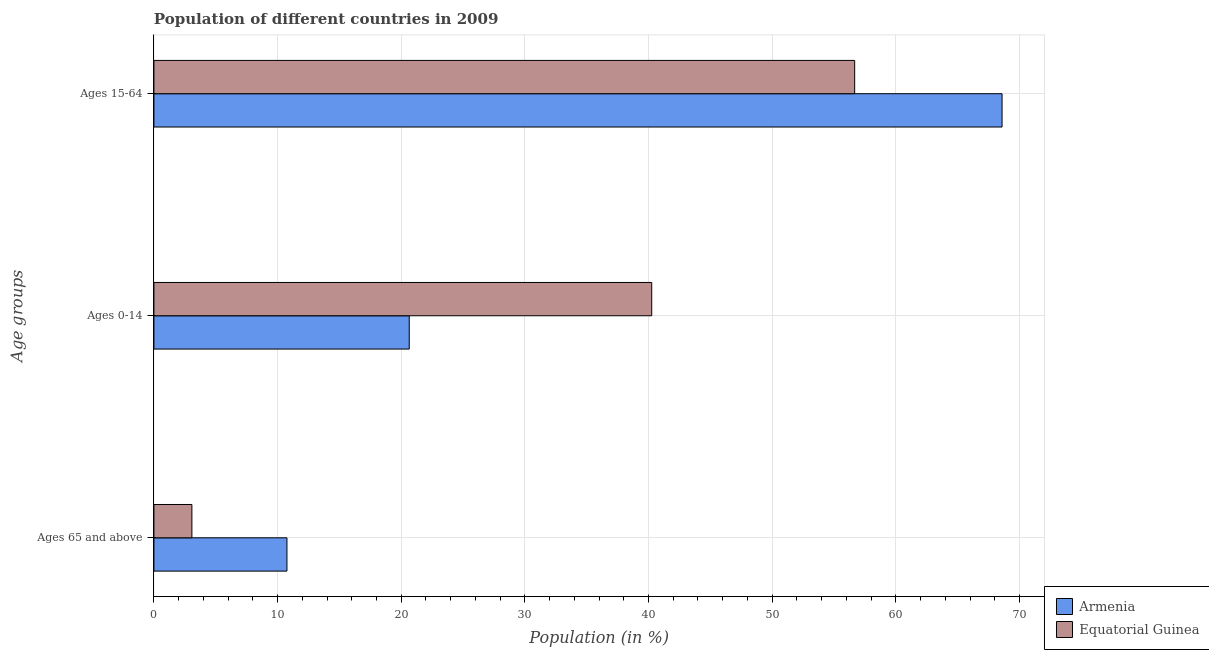How many groups of bars are there?
Offer a very short reply. 3. Are the number of bars on each tick of the Y-axis equal?
Give a very brief answer. Yes. How many bars are there on the 2nd tick from the bottom?
Your answer should be very brief. 2. What is the label of the 3rd group of bars from the top?
Keep it short and to the point. Ages 65 and above. What is the percentage of population within the age-group 0-14 in Armenia?
Keep it short and to the point. 20.65. Across all countries, what is the maximum percentage of population within the age-group of 65 and above?
Ensure brevity in your answer.  10.76. Across all countries, what is the minimum percentage of population within the age-group of 65 and above?
Offer a very short reply. 3.07. In which country was the percentage of population within the age-group of 65 and above maximum?
Your response must be concise. Armenia. In which country was the percentage of population within the age-group 0-14 minimum?
Provide a succinct answer. Armenia. What is the total percentage of population within the age-group 0-14 in the graph?
Your response must be concise. 60.91. What is the difference between the percentage of population within the age-group 0-14 in Armenia and that in Equatorial Guinea?
Offer a very short reply. -19.61. What is the difference between the percentage of population within the age-group 15-64 in Armenia and the percentage of population within the age-group 0-14 in Equatorial Guinea?
Your answer should be compact. 28.33. What is the average percentage of population within the age-group 15-64 per country?
Make the answer very short. 62.63. What is the difference between the percentage of population within the age-group 15-64 and percentage of population within the age-group 0-14 in Equatorial Guinea?
Your answer should be compact. 16.41. In how many countries, is the percentage of population within the age-group 15-64 greater than 6 %?
Provide a succinct answer. 2. What is the ratio of the percentage of population within the age-group 0-14 in Equatorial Guinea to that in Armenia?
Make the answer very short. 1.95. Is the difference between the percentage of population within the age-group of 65 and above in Equatorial Guinea and Armenia greater than the difference between the percentage of population within the age-group 15-64 in Equatorial Guinea and Armenia?
Keep it short and to the point. Yes. What is the difference between the highest and the second highest percentage of population within the age-group 0-14?
Make the answer very short. 19.61. What is the difference between the highest and the lowest percentage of population within the age-group 15-64?
Keep it short and to the point. 11.92. What does the 2nd bar from the top in Ages 15-64 represents?
Offer a very short reply. Armenia. What does the 1st bar from the bottom in Ages 65 and above represents?
Provide a succinct answer. Armenia. Is it the case that in every country, the sum of the percentage of population within the age-group of 65 and above and percentage of population within the age-group 0-14 is greater than the percentage of population within the age-group 15-64?
Make the answer very short. No. How many bars are there?
Ensure brevity in your answer.  6. Are all the bars in the graph horizontal?
Your answer should be compact. Yes. Are the values on the major ticks of X-axis written in scientific E-notation?
Offer a very short reply. No. Does the graph contain any zero values?
Make the answer very short. No. Does the graph contain grids?
Give a very brief answer. Yes. How are the legend labels stacked?
Provide a short and direct response. Vertical. What is the title of the graph?
Make the answer very short. Population of different countries in 2009. Does "Barbados" appear as one of the legend labels in the graph?
Keep it short and to the point. No. What is the label or title of the X-axis?
Your response must be concise. Population (in %). What is the label or title of the Y-axis?
Offer a very short reply. Age groups. What is the Population (in %) of Armenia in Ages 65 and above?
Your answer should be compact. 10.76. What is the Population (in %) in Equatorial Guinea in Ages 65 and above?
Offer a terse response. 3.07. What is the Population (in %) in Armenia in Ages 0-14?
Provide a short and direct response. 20.65. What is the Population (in %) of Equatorial Guinea in Ages 0-14?
Ensure brevity in your answer.  40.26. What is the Population (in %) in Armenia in Ages 15-64?
Provide a short and direct response. 68.59. What is the Population (in %) of Equatorial Guinea in Ages 15-64?
Your answer should be very brief. 56.67. Across all Age groups, what is the maximum Population (in %) of Armenia?
Make the answer very short. 68.59. Across all Age groups, what is the maximum Population (in %) of Equatorial Guinea?
Make the answer very short. 56.67. Across all Age groups, what is the minimum Population (in %) of Armenia?
Your answer should be compact. 10.76. Across all Age groups, what is the minimum Population (in %) of Equatorial Guinea?
Provide a succinct answer. 3.07. What is the total Population (in %) in Armenia in the graph?
Provide a short and direct response. 100. What is the difference between the Population (in %) of Armenia in Ages 65 and above and that in Ages 0-14?
Keep it short and to the point. -9.89. What is the difference between the Population (in %) of Equatorial Guinea in Ages 65 and above and that in Ages 0-14?
Offer a very short reply. -37.19. What is the difference between the Population (in %) of Armenia in Ages 65 and above and that in Ages 15-64?
Provide a short and direct response. -57.83. What is the difference between the Population (in %) of Equatorial Guinea in Ages 65 and above and that in Ages 15-64?
Provide a succinct answer. -53.6. What is the difference between the Population (in %) in Armenia in Ages 0-14 and that in Ages 15-64?
Provide a short and direct response. -47.94. What is the difference between the Population (in %) of Equatorial Guinea in Ages 0-14 and that in Ages 15-64?
Make the answer very short. -16.41. What is the difference between the Population (in %) in Armenia in Ages 65 and above and the Population (in %) in Equatorial Guinea in Ages 0-14?
Your answer should be very brief. -29.5. What is the difference between the Population (in %) in Armenia in Ages 65 and above and the Population (in %) in Equatorial Guinea in Ages 15-64?
Make the answer very short. -45.91. What is the difference between the Population (in %) of Armenia in Ages 0-14 and the Population (in %) of Equatorial Guinea in Ages 15-64?
Your answer should be very brief. -36.02. What is the average Population (in %) of Armenia per Age groups?
Give a very brief answer. 33.33. What is the average Population (in %) in Equatorial Guinea per Age groups?
Provide a succinct answer. 33.33. What is the difference between the Population (in %) in Armenia and Population (in %) in Equatorial Guinea in Ages 65 and above?
Your response must be concise. 7.69. What is the difference between the Population (in %) of Armenia and Population (in %) of Equatorial Guinea in Ages 0-14?
Give a very brief answer. -19.61. What is the difference between the Population (in %) of Armenia and Population (in %) of Equatorial Guinea in Ages 15-64?
Your answer should be very brief. 11.92. What is the ratio of the Population (in %) of Armenia in Ages 65 and above to that in Ages 0-14?
Your answer should be compact. 0.52. What is the ratio of the Population (in %) of Equatorial Guinea in Ages 65 and above to that in Ages 0-14?
Your response must be concise. 0.08. What is the ratio of the Population (in %) of Armenia in Ages 65 and above to that in Ages 15-64?
Offer a terse response. 0.16. What is the ratio of the Population (in %) in Equatorial Guinea in Ages 65 and above to that in Ages 15-64?
Give a very brief answer. 0.05. What is the ratio of the Population (in %) in Armenia in Ages 0-14 to that in Ages 15-64?
Provide a succinct answer. 0.3. What is the ratio of the Population (in %) in Equatorial Guinea in Ages 0-14 to that in Ages 15-64?
Provide a succinct answer. 0.71. What is the difference between the highest and the second highest Population (in %) in Armenia?
Offer a very short reply. 47.94. What is the difference between the highest and the second highest Population (in %) in Equatorial Guinea?
Provide a succinct answer. 16.41. What is the difference between the highest and the lowest Population (in %) in Armenia?
Offer a terse response. 57.83. What is the difference between the highest and the lowest Population (in %) of Equatorial Guinea?
Make the answer very short. 53.6. 